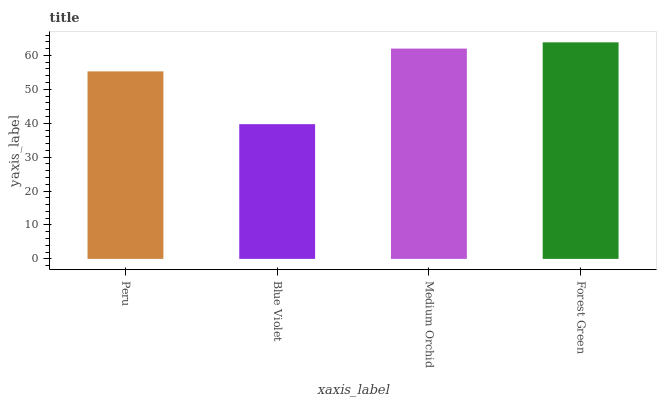Is Blue Violet the minimum?
Answer yes or no. Yes. Is Forest Green the maximum?
Answer yes or no. Yes. Is Medium Orchid the minimum?
Answer yes or no. No. Is Medium Orchid the maximum?
Answer yes or no. No. Is Medium Orchid greater than Blue Violet?
Answer yes or no. Yes. Is Blue Violet less than Medium Orchid?
Answer yes or no. Yes. Is Blue Violet greater than Medium Orchid?
Answer yes or no. No. Is Medium Orchid less than Blue Violet?
Answer yes or no. No. Is Medium Orchid the high median?
Answer yes or no. Yes. Is Peru the low median?
Answer yes or no. Yes. Is Peru the high median?
Answer yes or no. No. Is Blue Violet the low median?
Answer yes or no. No. 